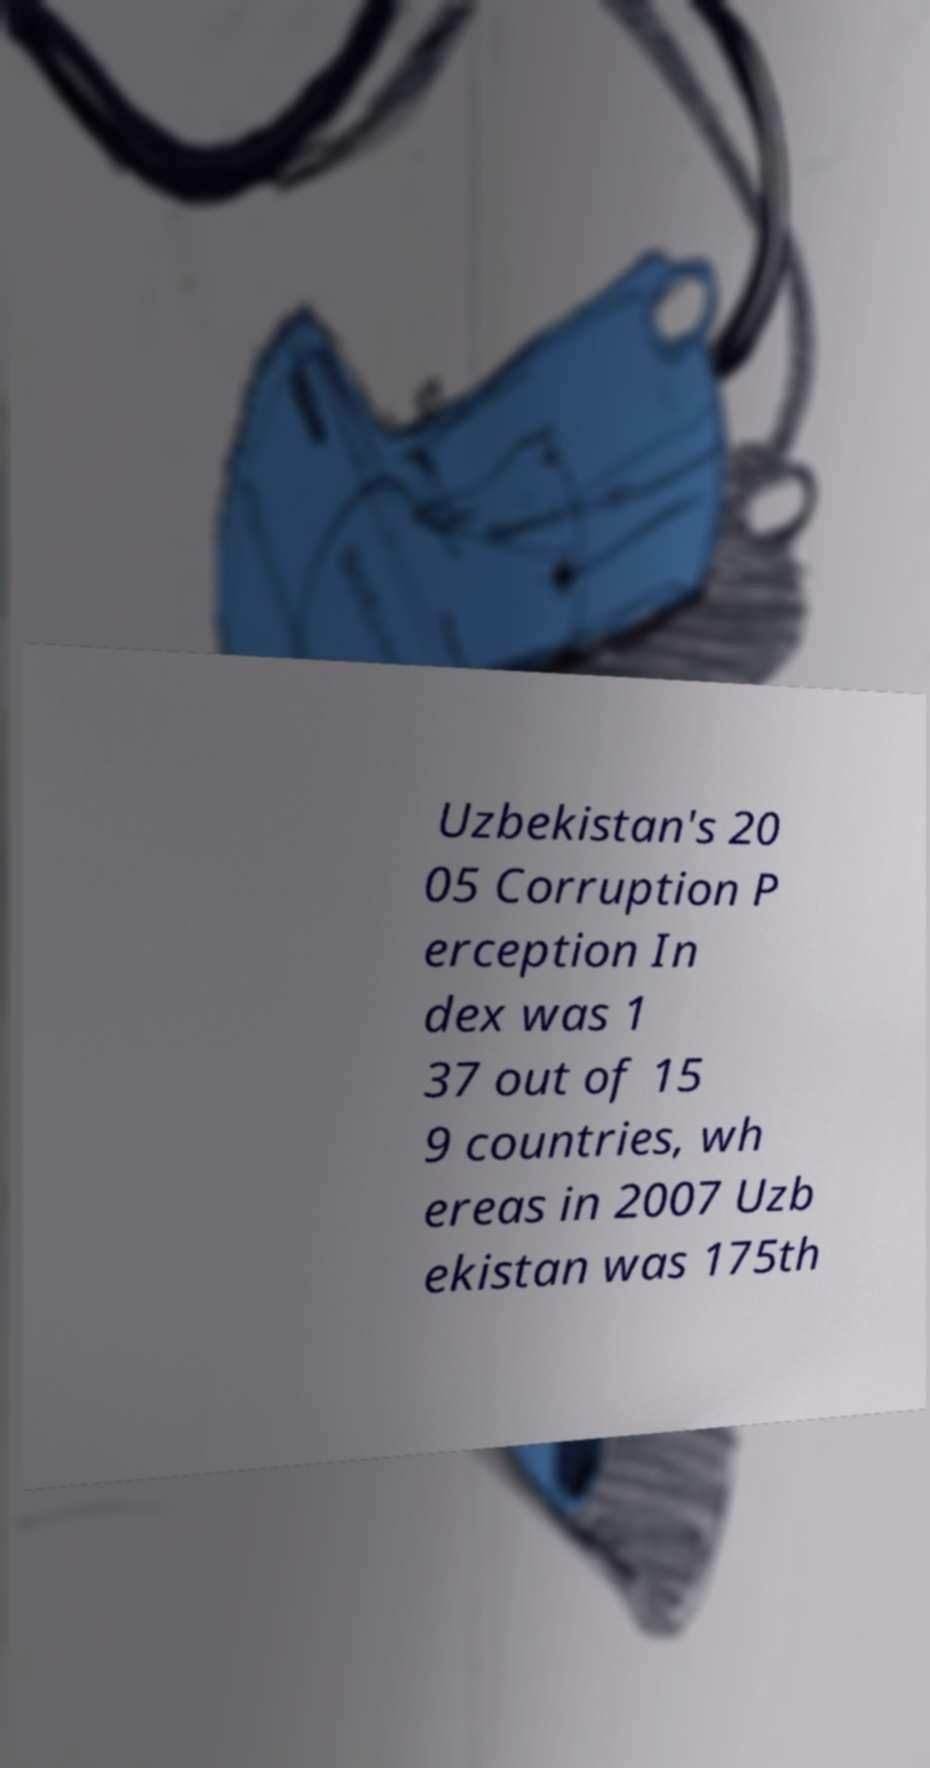I need the written content from this picture converted into text. Can you do that? Uzbekistan's 20 05 Corruption P erception In dex was 1 37 out of 15 9 countries, wh ereas in 2007 Uzb ekistan was 175th 